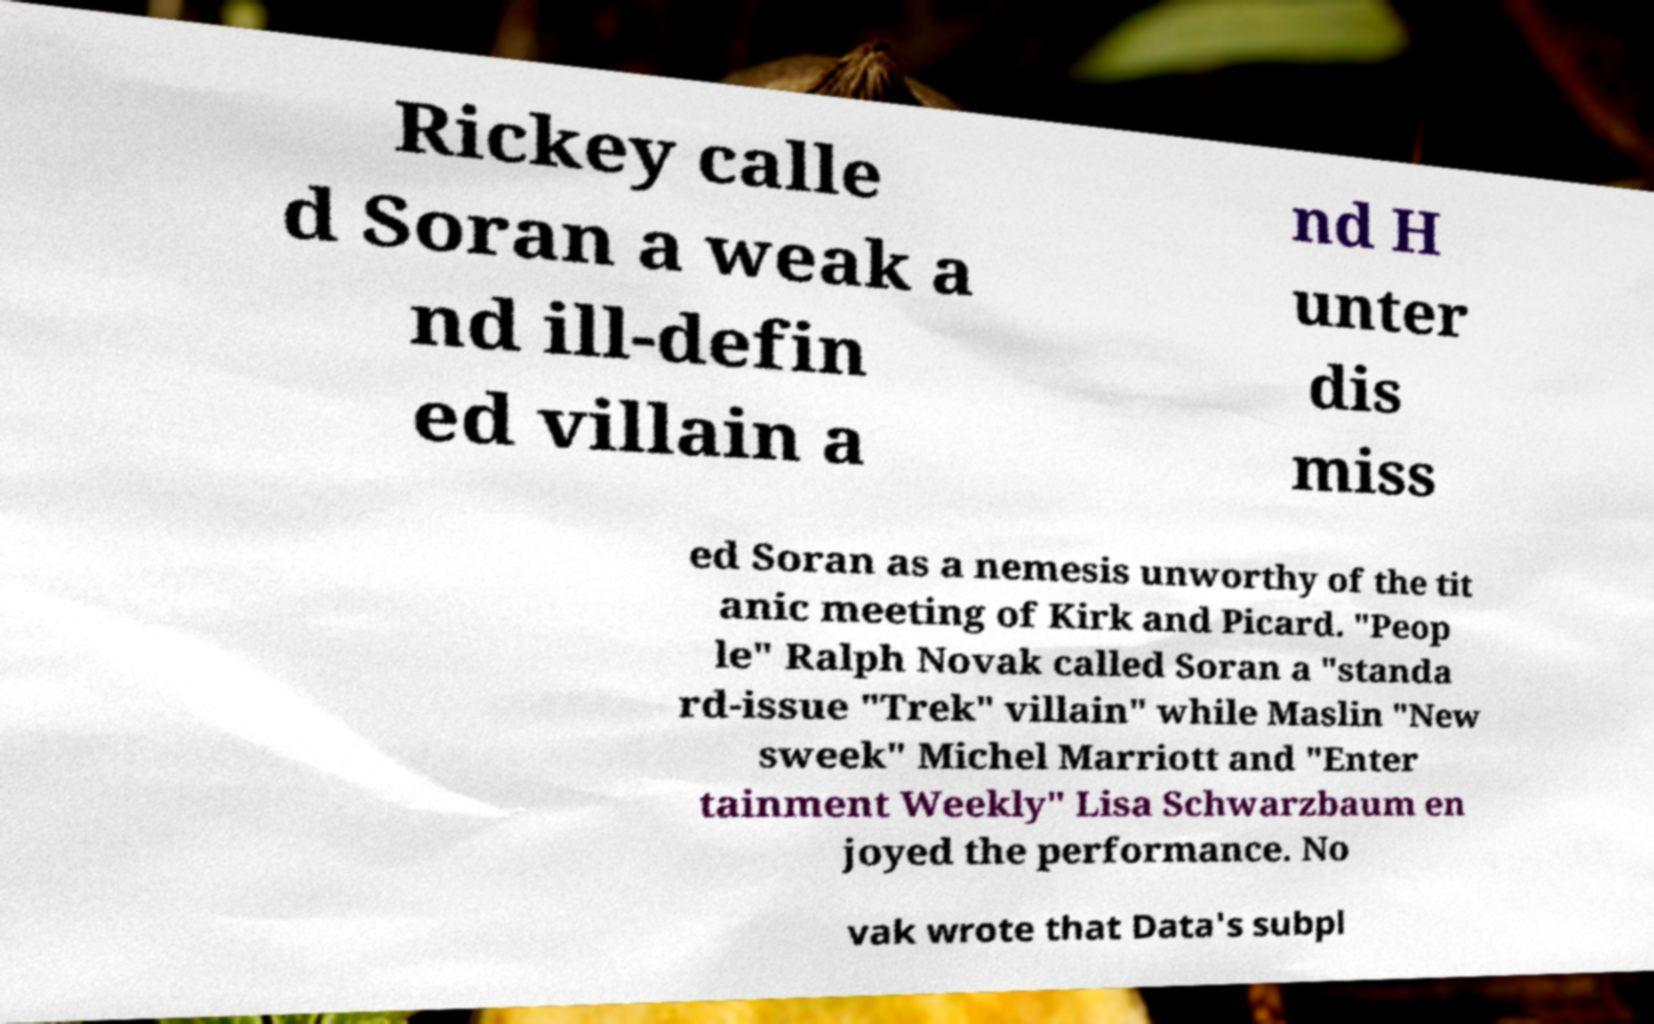Could you extract and type out the text from this image? Rickey calle d Soran a weak a nd ill-defin ed villain a nd H unter dis miss ed Soran as a nemesis unworthy of the tit anic meeting of Kirk and Picard. "Peop le" Ralph Novak called Soran a "standa rd-issue "Trek" villain" while Maslin "New sweek" Michel Marriott and "Enter tainment Weekly" Lisa Schwarzbaum en joyed the performance. No vak wrote that Data's subpl 